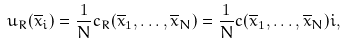Convert formula to latex. <formula><loc_0><loc_0><loc_500><loc_500>u _ { R } ( \overline { x } _ { i } ) = \frac { 1 } { N } c _ { R } ( \overline { x } _ { 1 } , \dots , \overline { x } _ { N } ) = \frac { 1 } { N } c ( \overline { x } _ { 1 } , \dots , \overline { x } _ { N } ) i ,</formula> 